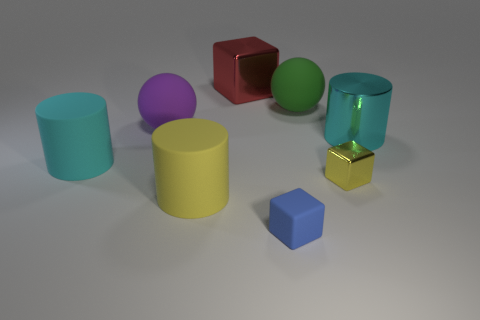Do the yellow cube and the cyan metal cylinder have the same size?
Provide a short and direct response. No. What number of objects are small blue matte cubes or cyan matte cylinders?
Your answer should be very brief. 2. Is the number of big rubber spheres that are in front of the small yellow metal block the same as the number of tiny blue rubber things?
Offer a very short reply. No. Is there a tiny yellow metal block right of the cyan object to the right of the yellow object that is right of the big red cube?
Provide a short and direct response. No. There is a cylinder that is made of the same material as the big red block; what color is it?
Make the answer very short. Cyan. There is a large object that is on the left side of the purple sphere; is it the same color as the metal cylinder?
Your answer should be compact. Yes. How many blocks are cyan rubber things or big purple objects?
Your response must be concise. 0. There is a red metallic block that is to the right of the large cylinder that is in front of the small cube that is behind the large yellow cylinder; what is its size?
Offer a very short reply. Large. What is the shape of the cyan thing that is the same size as the cyan shiny cylinder?
Give a very brief answer. Cylinder. There is a big green thing; what shape is it?
Offer a terse response. Sphere. 